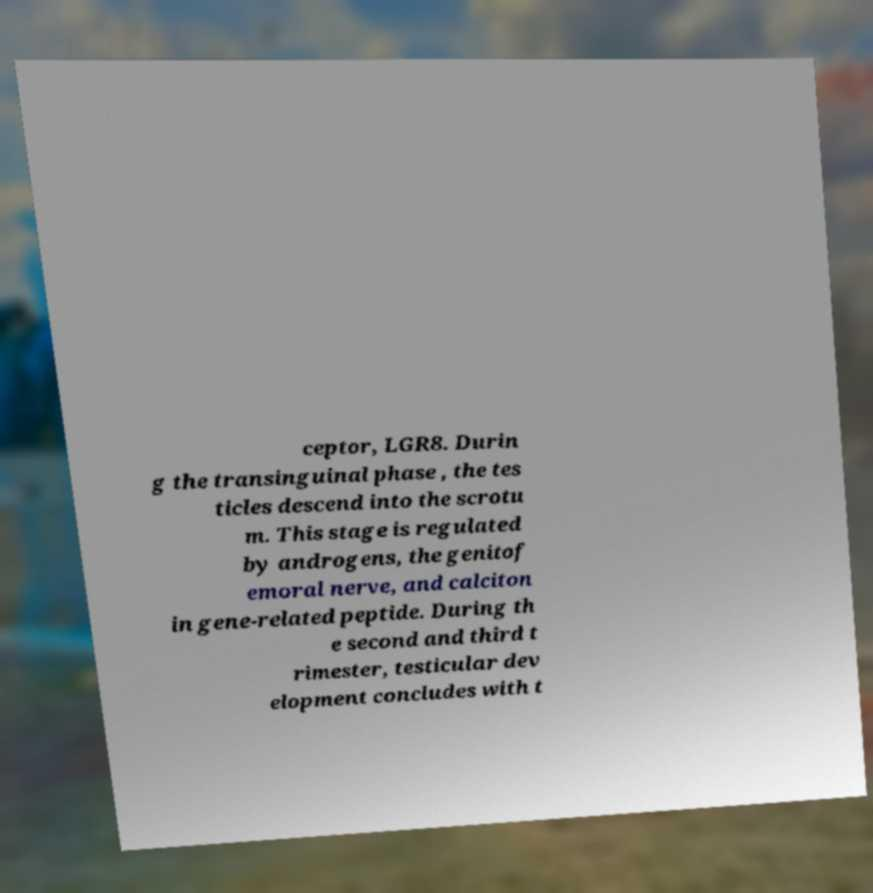Please identify and transcribe the text found in this image. ceptor, LGR8. Durin g the transinguinal phase , the tes ticles descend into the scrotu m. This stage is regulated by androgens, the genitof emoral nerve, and calciton in gene-related peptide. During th e second and third t rimester, testicular dev elopment concludes with t 